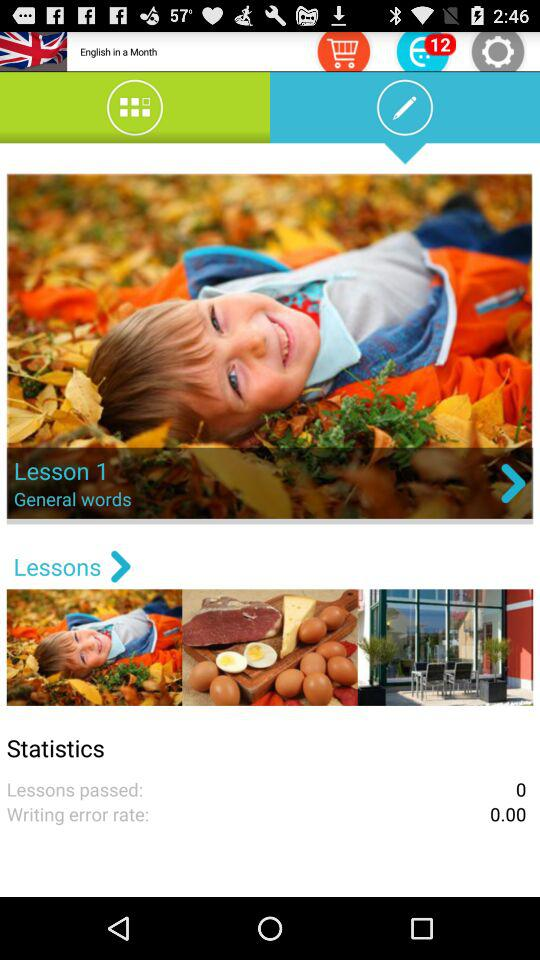How many lessons have been passed? The number of lessons that have been passed is 0. 